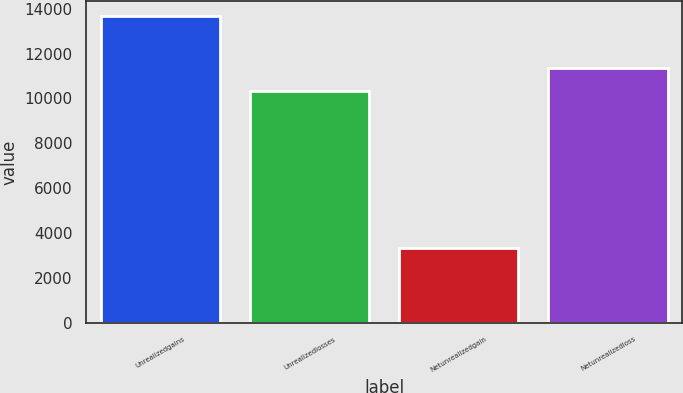<chart> <loc_0><loc_0><loc_500><loc_500><bar_chart><fcel>Unrealizedgains<fcel>Unrealizedlosses<fcel>Netunrealizedgain<fcel>Netunrealizedloss<nl><fcel>13666<fcel>10319<fcel>3347<fcel>11350.9<nl></chart> 